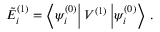<formula> <loc_0><loc_0><loc_500><loc_500>\tilde { E } _ { i } ^ { ( 1 ) } = \left \langle \psi _ { i } ^ { ( 0 ) } \right | V ^ { ( 1 ) } \left | \psi _ { i } ^ { ( 0 ) } \right \rangle \, .</formula> 